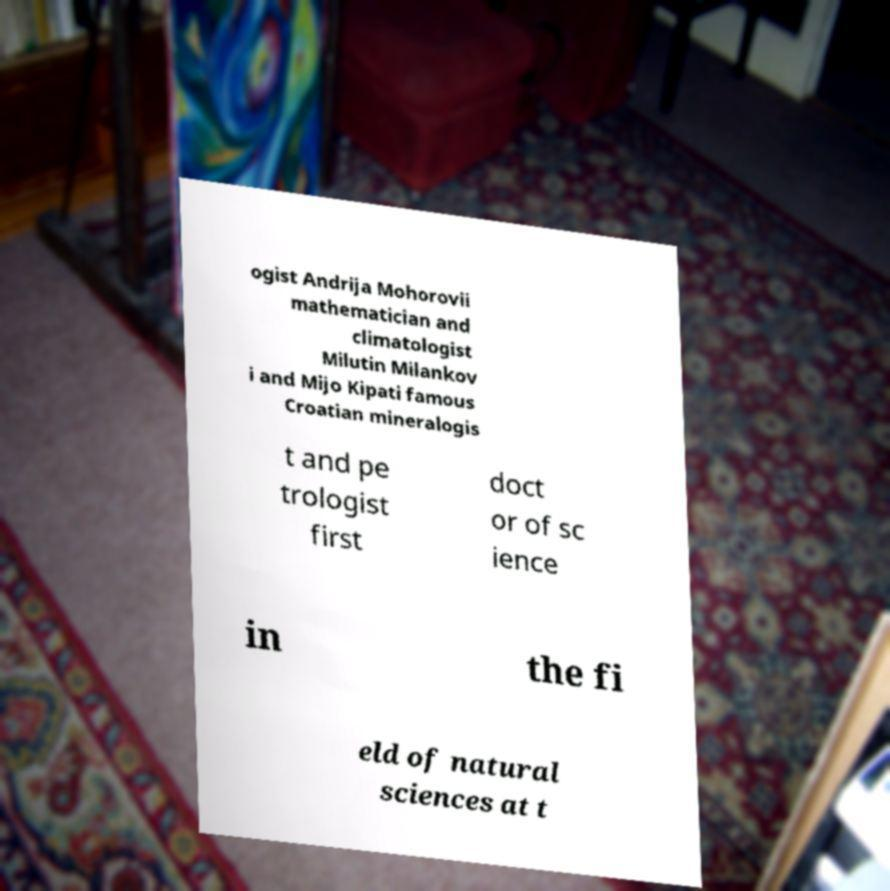Can you read and provide the text displayed in the image?This photo seems to have some interesting text. Can you extract and type it out for me? ogist Andrija Mohorovii mathematician and climatologist Milutin Milankov i and Mijo Kipati famous Croatian mineralogis t and pe trologist first doct or of sc ience in the fi eld of natural sciences at t 